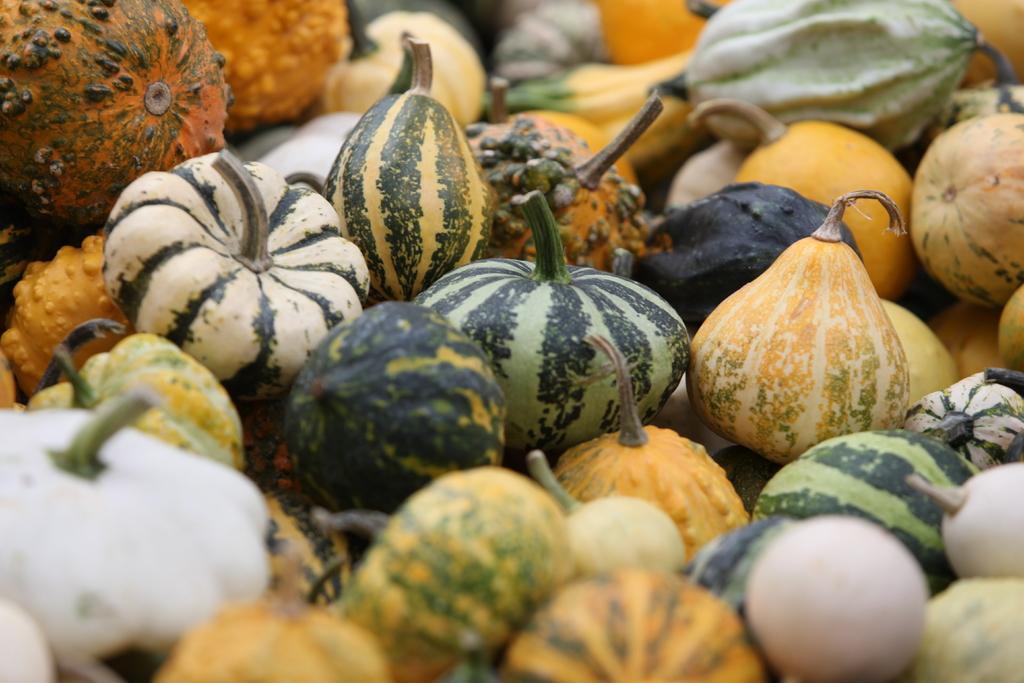In one or two sentences, can you explain what this image depicts? In this image there are vegetables and fruits. 